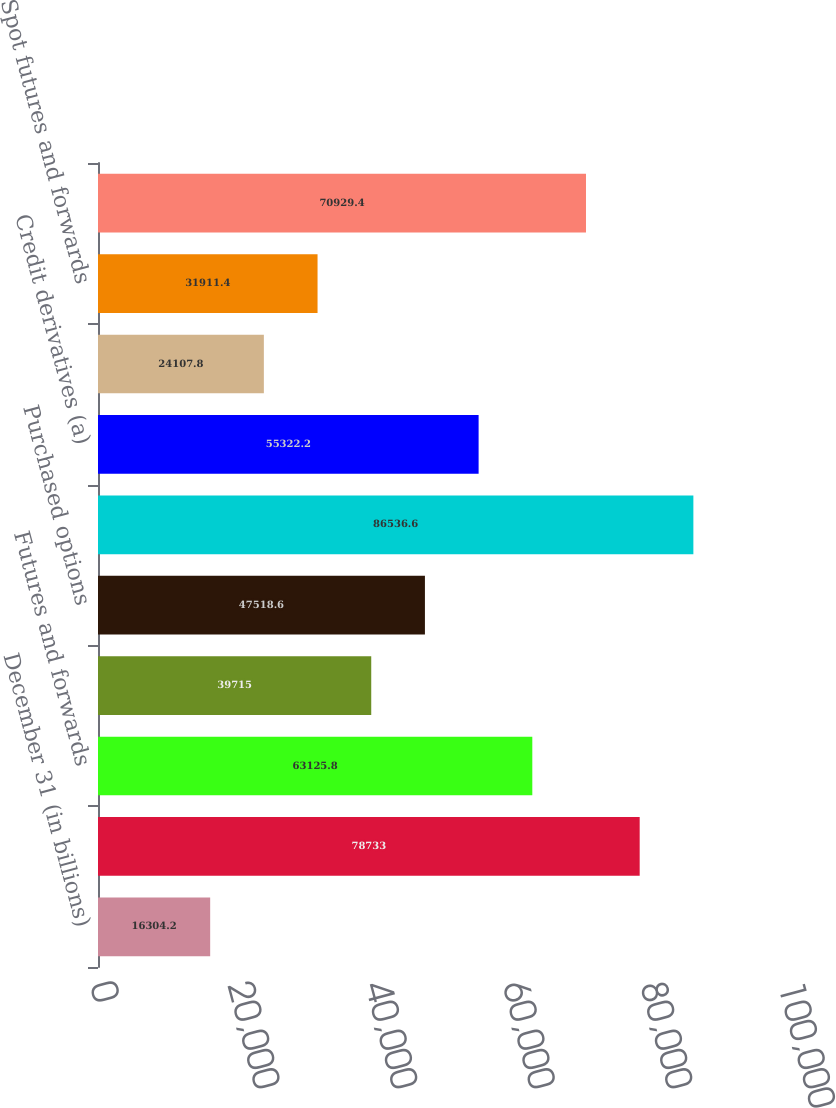Convert chart to OTSL. <chart><loc_0><loc_0><loc_500><loc_500><bar_chart><fcel>December 31 (in billions)<fcel>Swaps<fcel>Futures and forwards<fcel>Written options<fcel>Purchased options<fcel>Total interest rate contracts<fcel>Credit derivatives (a)<fcel>Cross-currency swaps<fcel>Spot futures and forwards<fcel>Total foreign exchange<nl><fcel>16304.2<fcel>78733<fcel>63125.8<fcel>39715<fcel>47518.6<fcel>86536.6<fcel>55322.2<fcel>24107.8<fcel>31911.4<fcel>70929.4<nl></chart> 